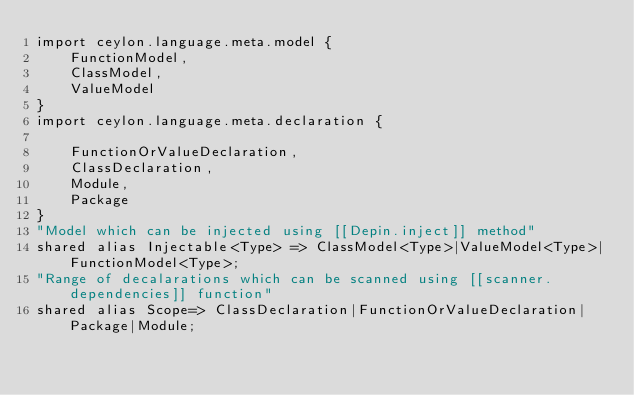<code> <loc_0><loc_0><loc_500><loc_500><_Ceylon_>import ceylon.language.meta.model {
	FunctionModel,
	ClassModel,
	ValueModel
}
import ceylon.language.meta.declaration {

	FunctionOrValueDeclaration,
	ClassDeclaration,
	Module,
	Package
}
"Model which can be injected using [[Depin.inject]] method" 
shared alias Injectable<Type> => ClassModel<Type>|ValueModel<Type>|FunctionModel<Type>;
"Range of decalarations which can be scanned using [[scanner.dependencies]] function"
shared alias Scope=> ClassDeclaration|FunctionOrValueDeclaration|Package|Module;</code> 